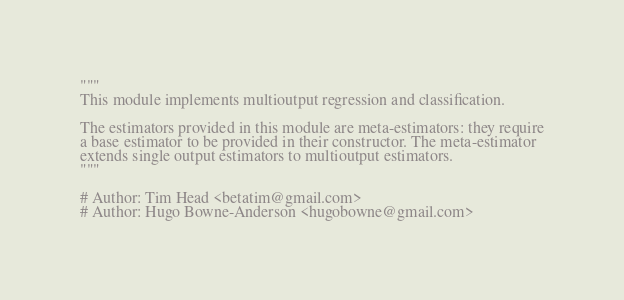<code> <loc_0><loc_0><loc_500><loc_500><_Python_>"""
This module implements multioutput regression and classification.

The estimators provided in this module are meta-estimators: they require
a base estimator to be provided in their constructor. The meta-estimator
extends single output estimators to multioutput estimators.
"""

# Author: Tim Head <betatim@gmail.com>
# Author: Hugo Bowne-Anderson <hugobowne@gmail.com></code> 